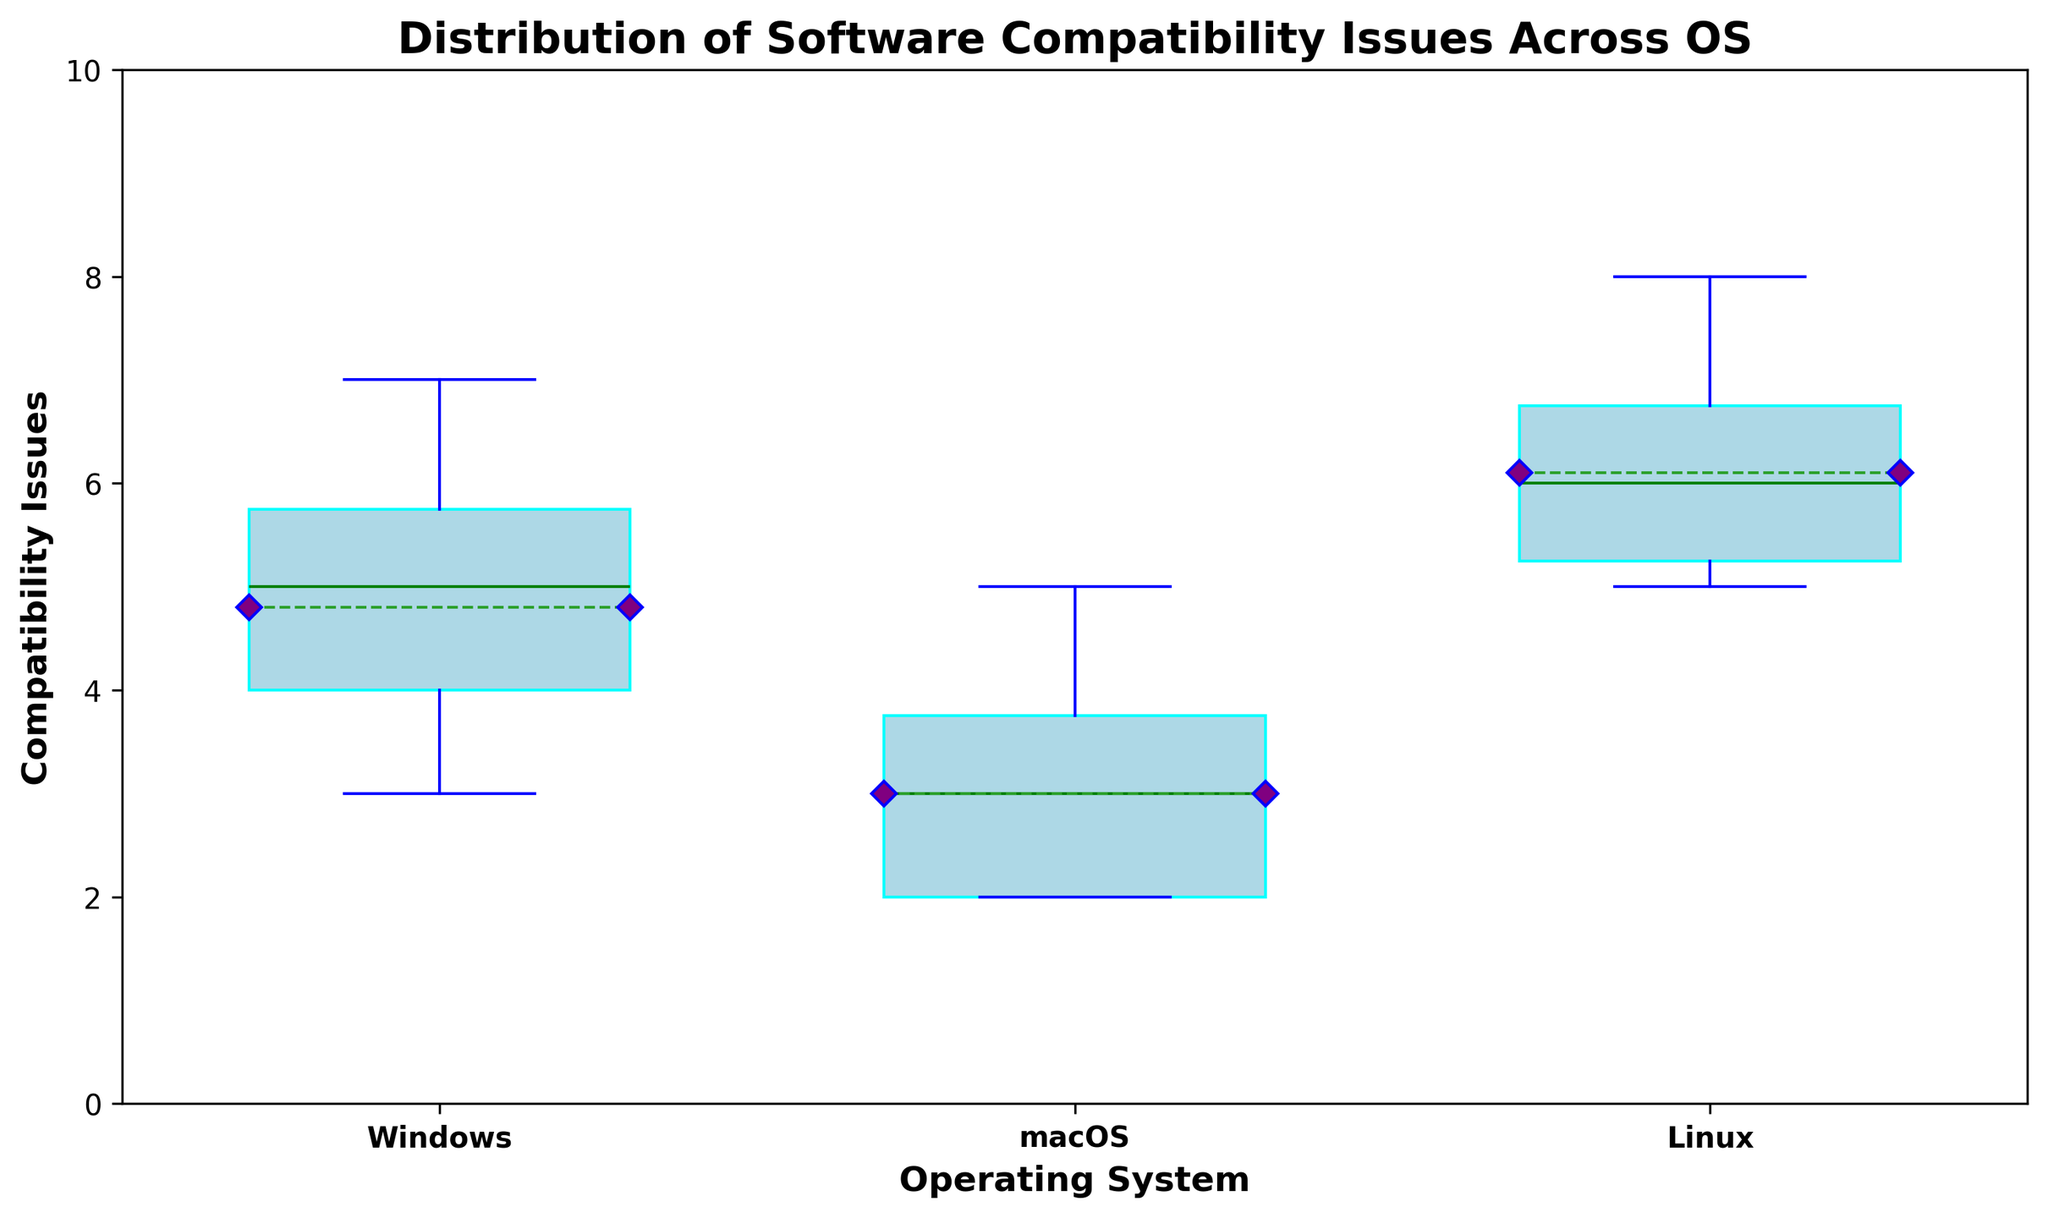What's the median number of compatibility issues for Windows? The median value is the middle number in a sorted list. The sorted list of compatibility issues for Windows is [3, 3, 4, 4, 5, 5, 5, 6, 6, 7], so the middle numbers are 5 and 5, and their average is (5+5)/2.
Answer: 5 Which operating system has the highest mean number of compatibility issues? The box plot shows the means marked with a purple diamond. Comparing the positions of these diamonds, the one for Linux is the highest.
Answer: Linux How does the variability of compatibility issues compare between macOS and Linux? The height of the box represents the interquartile range (IQR). macOS has a shorter box compared to Linux, indicating lower variability in macOS.
Answer: macOS has lower variability What's the range of compatibility issues for Windows? The range is calculated as the difference between the maximum and minimum values. For Windows, the minimum is 3 and the maximum is 7, so the range is 7 - 3.
Answer: 4 Between Windows and macOS, which has the lower third quartile of compatibility issues? The third quartile (Q3) is the top of the box. Visually inspecting the box plot, the top of the box for macOS is lower than that for Windows.
Answer: macOS In which operating system are outliers most prominent? Outliers are indicated by red circles. Windows and Linux have some outliers, but macOS has none.
Answer: Windows and Linux What's the median number of compatibility issues for macOS compared to Linux? The median is indicated by the green line inside the box. Comparing these green lines, macOS has a lower median than Linux.
Answer: macOS has a lower median Are there more extreme values for compatibility issues in Linux or in Windows? Extreme values are indicated by the position of the outliers. Linux has outliers that are higher in value compared to Windows.
Answer: Linux How does the interquartile range (IQR) of Windows compare to macOS? The IQR is the height of the box. Windows has a taller box compared to macOS, indicating a larger IQR.
Answer: Windows has a larger IQR Which operating system has the least variability in compatibility issues? The smallest IQR, indicated by the shortest box, represents the least variability. macOS has the shortest box.
Answer: macOS 